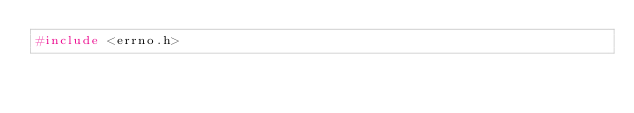<code> <loc_0><loc_0><loc_500><loc_500><_C_>#include <errno.h>
</code> 